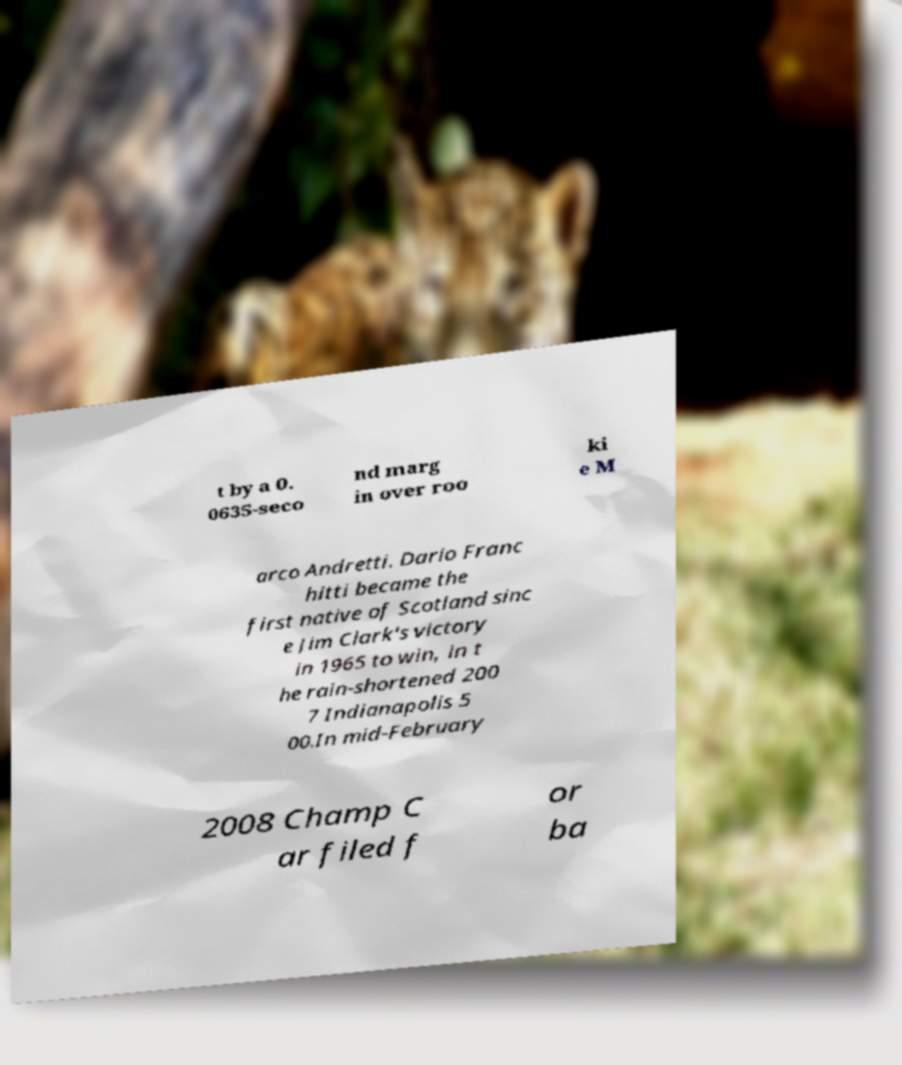What messages or text are displayed in this image? I need them in a readable, typed format. t by a 0. 0635-seco nd marg in over roo ki e M arco Andretti. Dario Franc hitti became the first native of Scotland sinc e Jim Clark's victory in 1965 to win, in t he rain-shortened 200 7 Indianapolis 5 00.In mid-February 2008 Champ C ar filed f or ba 